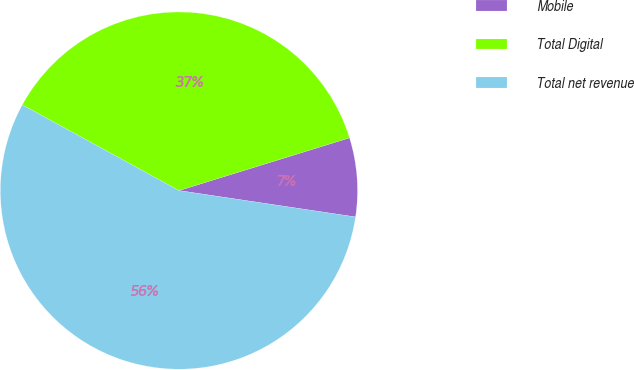Convert chart. <chart><loc_0><loc_0><loc_500><loc_500><pie_chart><fcel>Mobile<fcel>Total Digital<fcel>Total net revenue<nl><fcel>7.13%<fcel>37.26%<fcel>55.62%<nl></chart> 